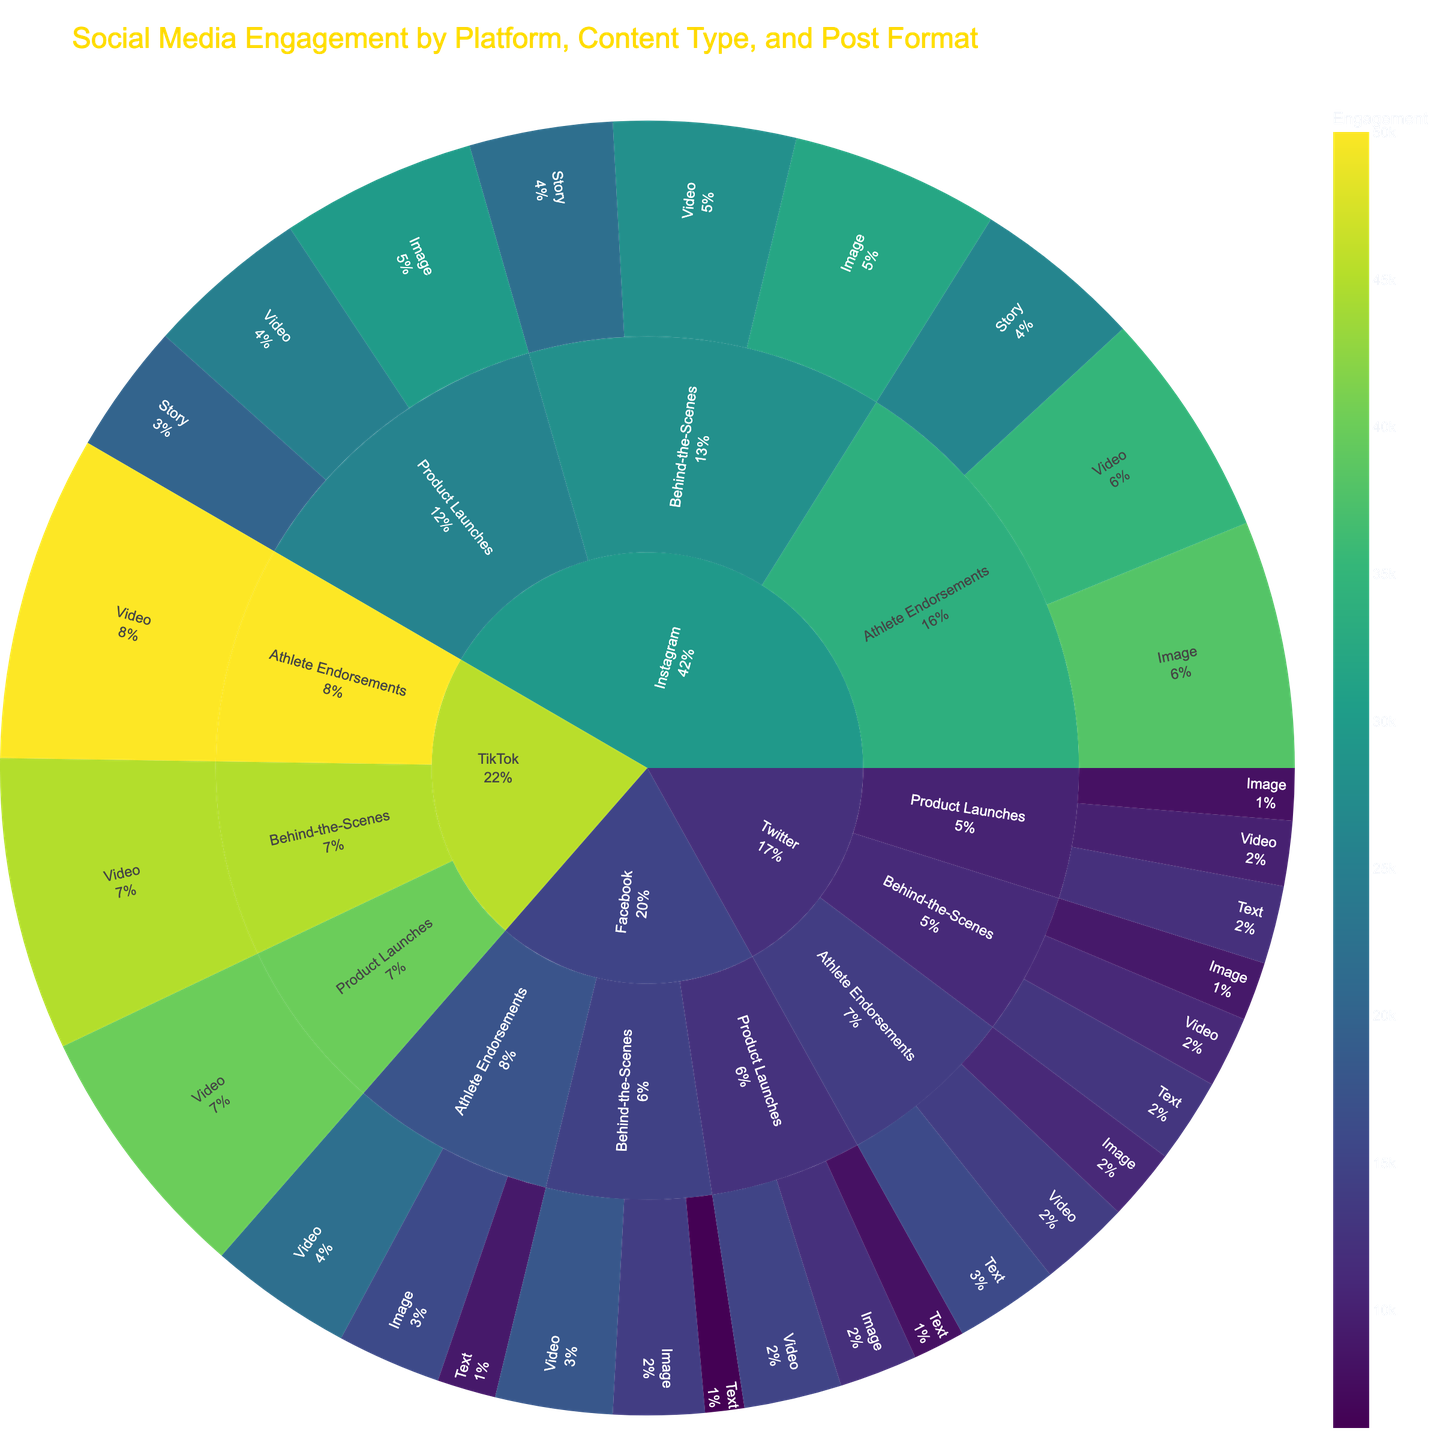What's the most engaging post format for Athlete Endorsements on Instagram? To answer this, locate the Instagram section within Athlete Endorsements and observe the engagement values for each post format (Video, Image, and Story). The highest engagement value will indicate the most engaging format.
Answer: Image Which platform has the highest overall engagement for Behind-the-Scenes content? Look at the sum of engagement values for Behind-the-Scenes content on each platform: Facebook, Instagram, Twitter, and TikTok. Compare these sums to identify the highest.
Answer: TikTok What is the engagement difference between Video and Image posts for Product Launches on Facebook? Identify the engagement values for Video (15,000) and Image (12,000) posts for Product Launches on Facebook. Subtract the engagement of Image posts from Video posts to find the difference.
Answer: 3,000 How does engagement for TikTok Behind-the-Scenes videos compare to Instagram Behind-the-Scenes videos? Locate the engagement values for Behind-the-Scenes videos on TikTok (45,000) and Instagram (28,000). Compare these values to determine if TikTok is greater than Instagram.
Answer: TikTok has higher engagement Which type of content on Twitter has the highest engagement? Examine the Twitter section and compare engagement values across Product Launches, Behind-the-Scenes, and Athlete Endorsements. Identify which content type has the highest engagement.
Answer: Athlete Endorsements What is the total engagement for all post formats of Behind-the-Scenes content on Facebook? Sum the engagement values for Video (18,000), Image (14,000), and Text (6,000) posts for Behind-the-Scenes content on Facebook.
Answer: 38,000 Is the engagement for Product Launch texts higher on Twitter or Facebook? Observe the engagement values for Product Launch text posts on Twitter (12,000) and Facebook (8,000). Determine which platform has higher engagement.
Answer: Twitter Compare the engagement of Instagram and Facebook for all Athlete Endorsements posts. Sum the engagement values for all post formats under Athlete Endorsements for both Instagram (35,000 + 38,000 + 26,000) and Facebook (22,000 + 16,000 + 9,000). Compare the totals.
Answer: Instagram has higher engagement What's the least engaging post format for Behind-the-Scenes content on Twitter? Locate the engagement values for Behind-the-Scenes content on Twitter, specifically for Video, Image, and Text. Identify the format with the lowest value.
Answer: Image Which content type has higher engagement on Instagram: Product Launches or Athlete Endorsements? Sum the engagement values for all post formats under Product Launches (25,000 + 30,000 + 20,000) and Athlete Endorsements (35,000 + 38,000 + 26,000) on Instagram. Compare these totals.
Answer: Athlete Endorsements 